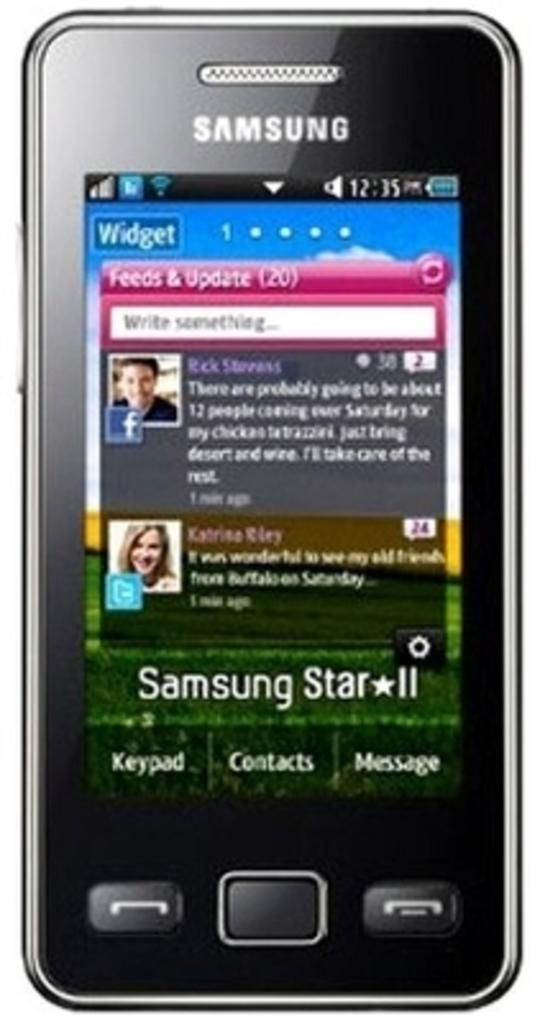<image>
Provide a brief description of the given image. A Samsung smart phone that shows it to be 12:35. 